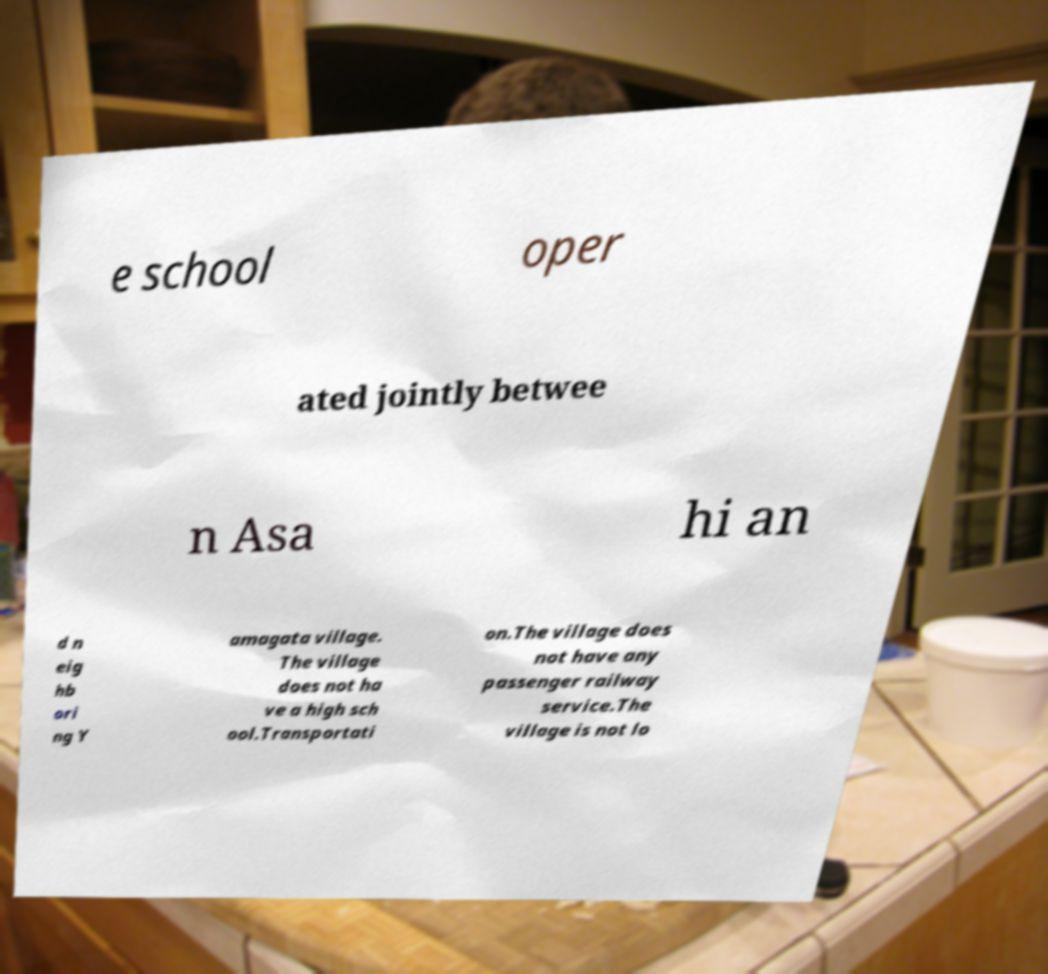Could you assist in decoding the text presented in this image and type it out clearly? e school oper ated jointly betwee n Asa hi an d n eig hb ori ng Y amagata village. The village does not ha ve a high sch ool.Transportati on.The village does not have any passenger railway service.The village is not lo 